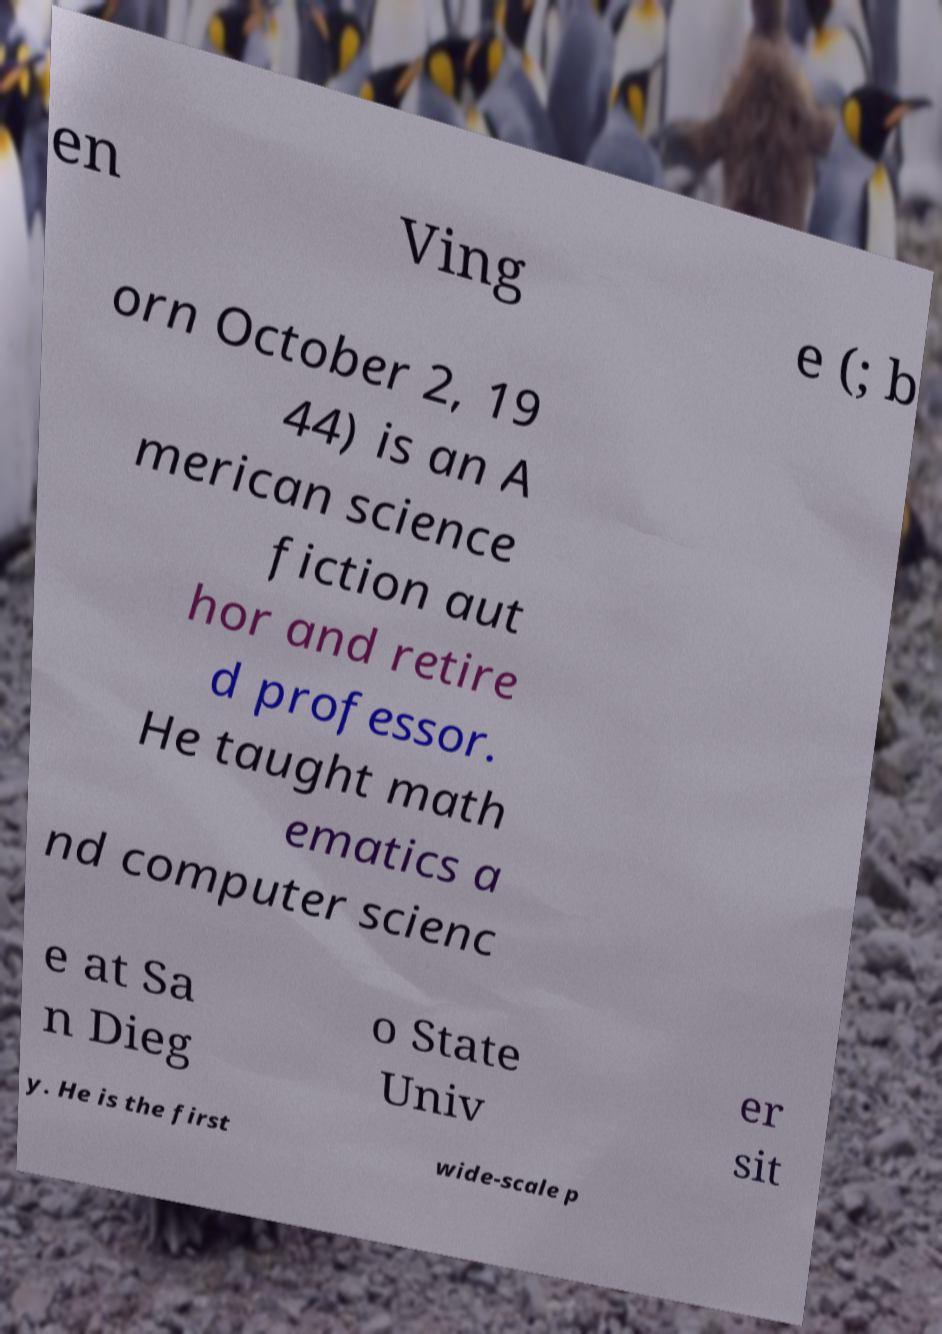What messages or text are displayed in this image? I need them in a readable, typed format. en Ving e (; b orn October 2, 19 44) is an A merican science fiction aut hor and retire d professor. He taught math ematics a nd computer scienc e at Sa n Dieg o State Univ er sit y. He is the first wide-scale p 